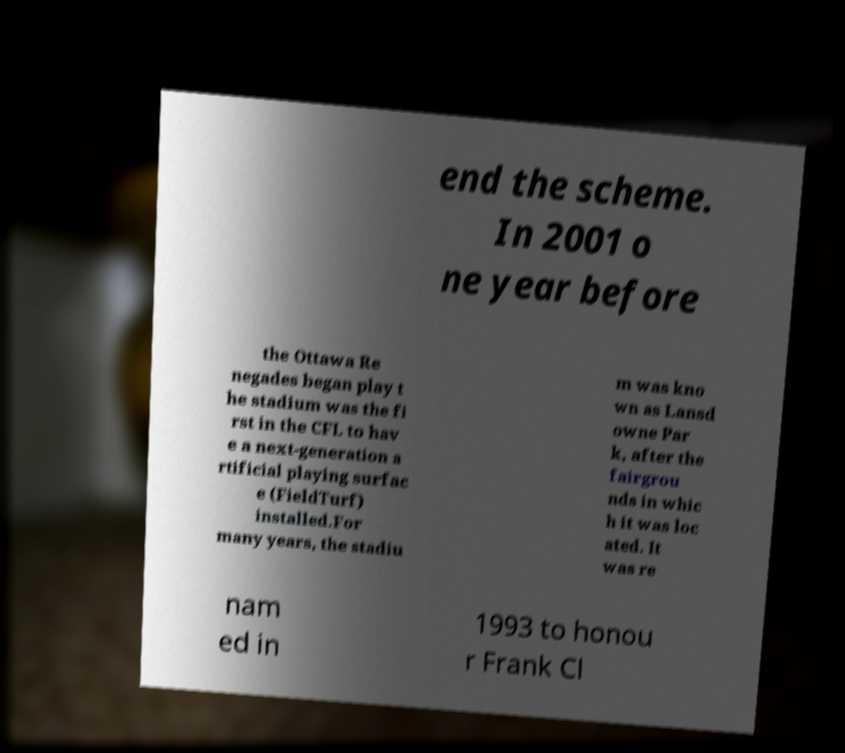Can you accurately transcribe the text from the provided image for me? end the scheme. In 2001 o ne year before the Ottawa Re negades began play t he stadium was the fi rst in the CFL to hav e a next-generation a rtificial playing surfac e (FieldTurf) installed.For many years, the stadiu m was kno wn as Lansd owne Par k, after the fairgrou nds in whic h it was loc ated. It was re nam ed in 1993 to honou r Frank Cl 